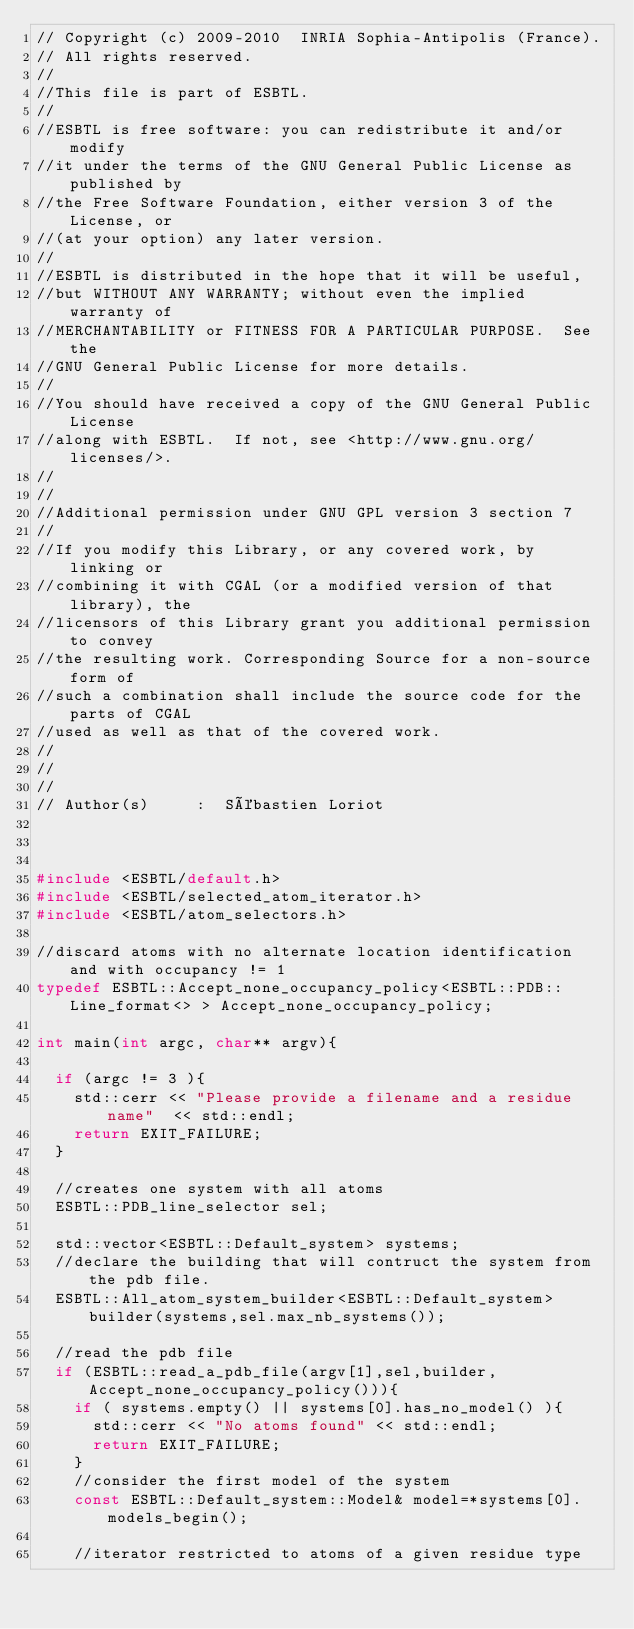<code> <loc_0><loc_0><loc_500><loc_500><_C++_>// Copyright (c) 2009-2010  INRIA Sophia-Antipolis (France).
// All rights reserved.
//
//This file is part of ESBTL.
//
//ESBTL is free software: you can redistribute it and/or modify
//it under the terms of the GNU General Public License as published by
//the Free Software Foundation, either version 3 of the License, or
//(at your option) any later version.
//
//ESBTL is distributed in the hope that it will be useful,
//but WITHOUT ANY WARRANTY; without even the implied warranty of
//MERCHANTABILITY or FITNESS FOR A PARTICULAR PURPOSE.  See the
//GNU General Public License for more details.
//
//You should have received a copy of the GNU General Public License
//along with ESBTL.  If not, see <http://www.gnu.org/licenses/>.
//
//
//Additional permission under GNU GPL version 3 section 7
//
//If you modify this Library, or any covered work, by linking or
//combining it with CGAL (or a modified version of that library), the
//licensors of this Library grant you additional permission to convey
//the resulting work. Corresponding Source for a non-source form of
//such a combination shall include the source code for the parts of CGAL
//used as well as that of the covered work. 
//
//
//
// Author(s)     :  Sébastien Loriot



#include <ESBTL/default.h>
#include <ESBTL/selected_atom_iterator.h>
#include <ESBTL/atom_selectors.h>

//discard atoms with no alternate location identification and with occupancy != 1
typedef ESBTL::Accept_none_occupancy_policy<ESBTL::PDB::Line_format<> > Accept_none_occupancy_policy;

int main(int argc, char** argv){
  
  if (argc != 3 ){
    std::cerr << "Please provide a filename and a residue name"  << std::endl;  
    return EXIT_FAILURE;
  }
  
  //creates one system with all atoms
  ESBTL::PDB_line_selector sel;
  
  std::vector<ESBTL::Default_system> systems;
  //declare the building that will contruct the system from the pdb file.
  ESBTL::All_atom_system_builder<ESBTL::Default_system> builder(systems,sel.max_nb_systems());
  
  //read the pdb file
  if (ESBTL::read_a_pdb_file(argv[1],sel,builder,Accept_none_occupancy_policy())){
    if ( systems.empty() || systems[0].has_no_model() ){
      std::cerr << "No atoms found" << std::endl;
      return EXIT_FAILURE;
    }
    //consider the first model of the system
    const ESBTL::Default_system::Model& model=*systems[0].models_begin();

    //iterator restricted to atoms of a given residue type</code> 